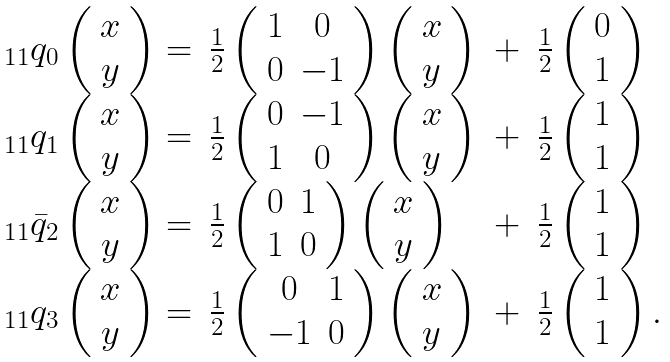Convert formula to latex. <formula><loc_0><loc_0><loc_500><loc_500>\begin{array} { l l l l } _ { 1 1 } q _ { 0 } \left ( \begin{array} { c } x \\ y \end{array} \right ) = & \frac { 1 } { 2 } \left ( \begin{array} { c c } 1 & 0 \\ 0 & - 1 \end{array} \right ) \left ( \begin{array} { c } x \\ y \end{array} \right ) & + & \frac { 1 } { 2 } \left ( \begin{array} { c } 0 \\ 1 \end{array} \right ) \\ _ { 1 1 } q _ { 1 } \left ( \begin{array} { c } x \\ y \end{array} \right ) = & \frac { 1 } { 2 } \left ( \begin{array} { c c } 0 & - 1 \\ 1 & 0 \end{array} \right ) \left ( \begin{array} { c } x \\ y \end{array} \right ) & + & \frac { 1 } { 2 } \left ( \begin{array} { c } 1 \\ 1 \end{array} \right ) \\ _ { 1 1 } \bar { q } _ { 2 } \left ( \begin{array} { c } x \\ y \end{array} \right ) = & \frac { 1 } { 2 } \left ( \begin{array} { c c } 0 & 1 \\ 1 & 0 \end{array} \right ) \left ( \begin{array} { c } x \\ y \end{array} \right ) & + & \frac { 1 } { 2 } \left ( \begin{array} { c } 1 \\ 1 \end{array} \right ) \\ _ { 1 1 } q _ { 3 } \left ( \begin{array} { c } x \\ y \end{array} \right ) = & \frac { 1 } { 2 } \left ( \begin{array} { c c } 0 & 1 \\ - 1 & 0 \end{array} \right ) \left ( \begin{array} { c } x \\ y \end{array} \right ) & + & \frac { 1 } { 2 } \left ( \begin{array} { c } 1 \\ 1 \end{array} \right ) . \\ \end{array}</formula> 